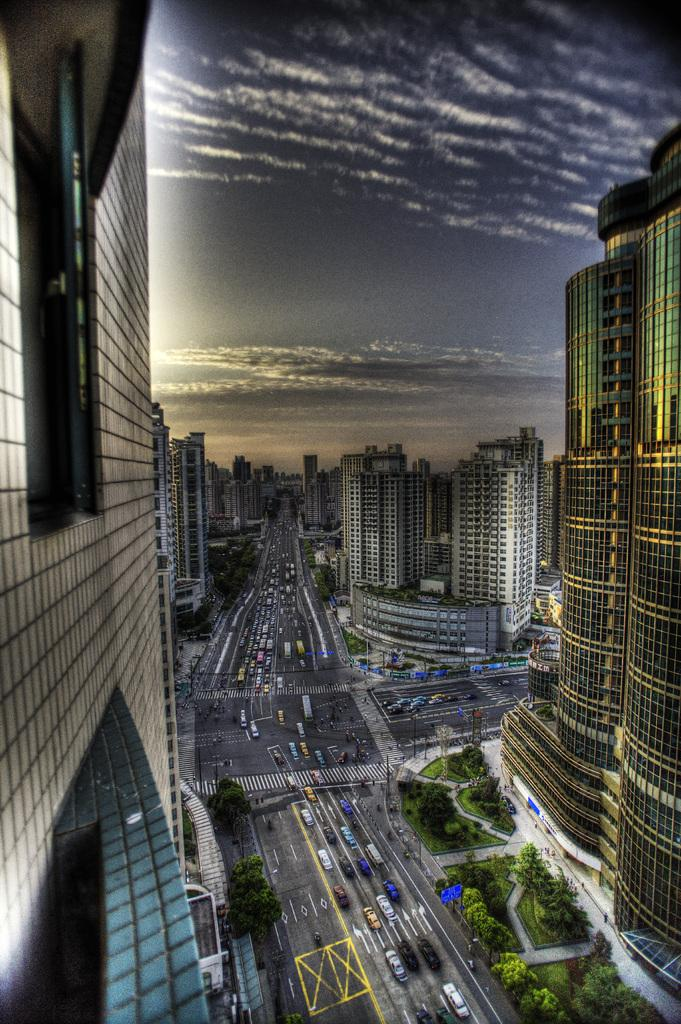What type of structures are present in the image? There are buildings in the image. What can be seen in the middle of the image? There are cars in the middle of the image. What is visible at the top of the image? The sky is visible at the top of the image. What type of vegetation is at the bottom of the image? There are trees at the bottom of the image. What type of discovery is being made in the image? There is no indication of a discovery being made in the image. Can you tell me where the church is located in the image? There is no church present in the image. 